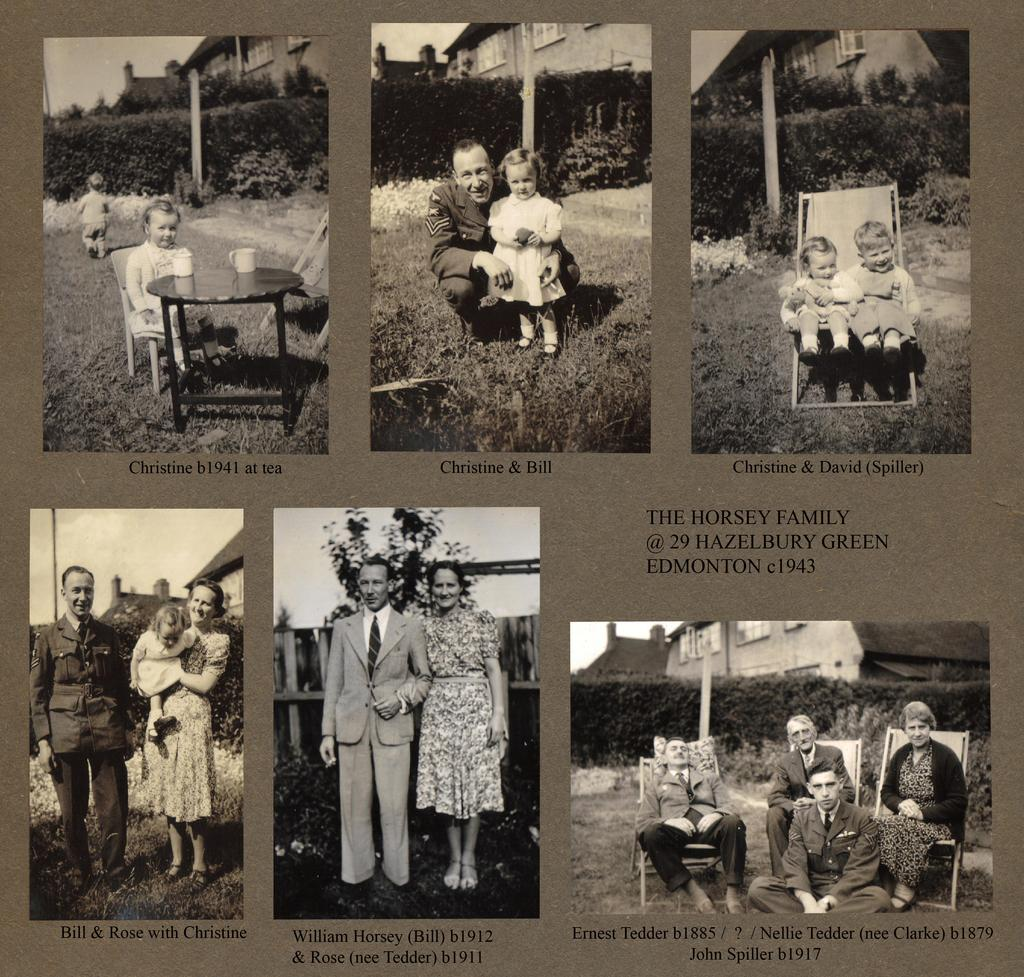What is the main subject of the poster in the image? The poster contains images of people, cars, buildings, trees, plants, and a table. What type of images can be seen on the poster? The poster contains images of people, cars, buildings, trees, plants, and a table. Is there any text on the poster? Yes, there is text on the poster. What type of story is being told by the poster? The poster does not tell a story; it is a collection of images and text. Can you describe the throne depicted in the poster? There is no throne present in the poster; it contains images of people, cars, buildings, trees, plants, and a table. 